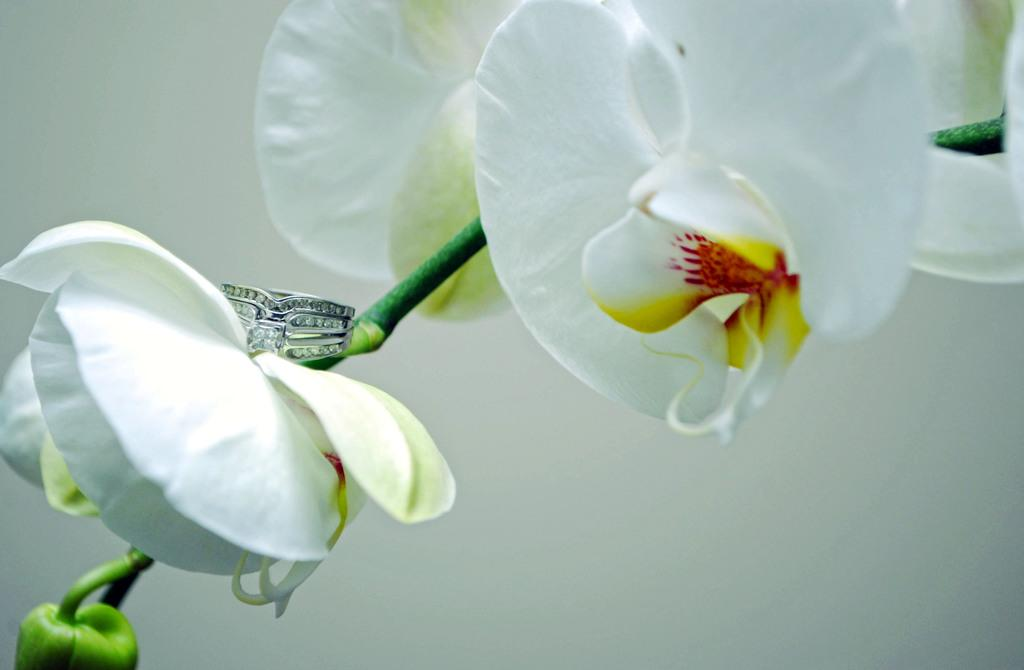What type of flowers are present in the image? There are white flowers in the image. What object can be seen in addition to the flowers? There is a ring in the image. What color is the background behind the flowers? The background behind the flowers is white. What type of fang can be seen in the image? There is no fang present in the image; it features white flowers and a ring. What type of lunch is being served in the image? There is no lunch or food present in the image. 